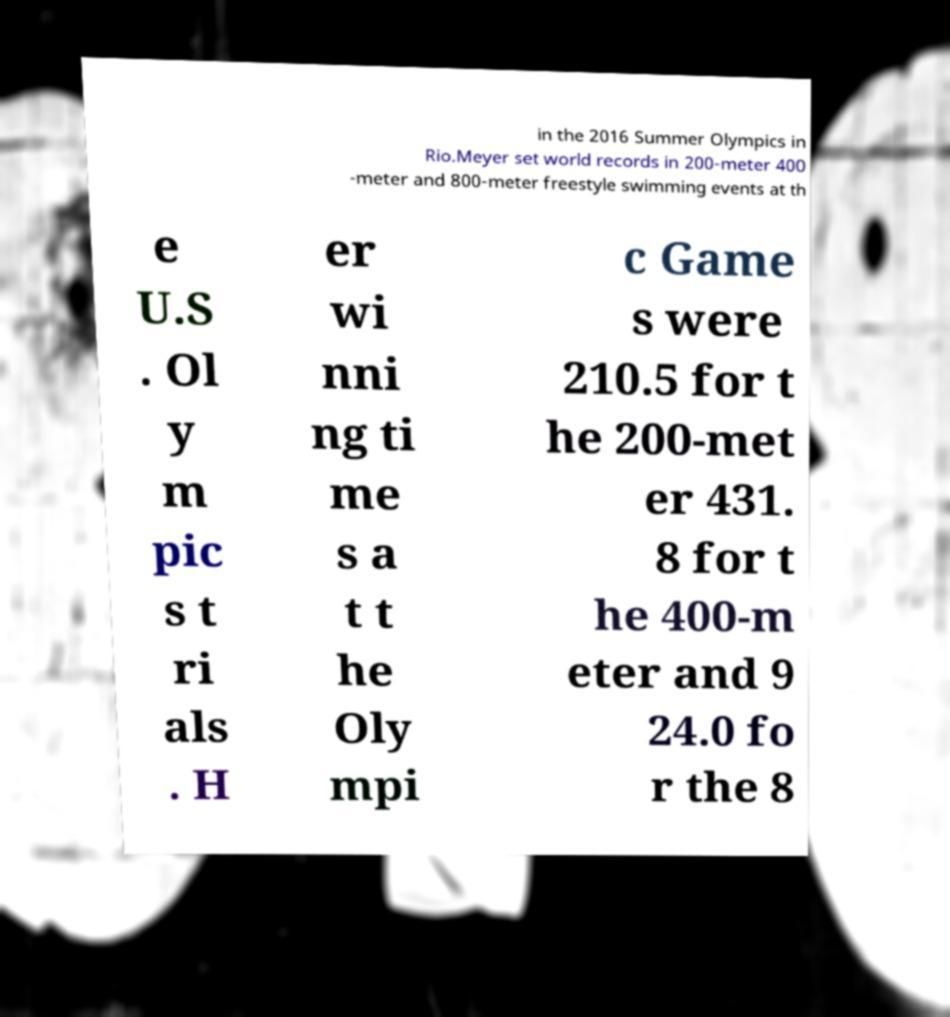There's text embedded in this image that I need extracted. Can you transcribe it verbatim? in the 2016 Summer Olympics in Rio.Meyer set world records in 200-meter 400 -meter and 800-meter freestyle swimming events at th e U.S . Ol y m pic s t ri als . H er wi nni ng ti me s a t t he Oly mpi c Game s were 210.5 for t he 200-met er 431. 8 for t he 400-m eter and 9 24.0 fo r the 8 